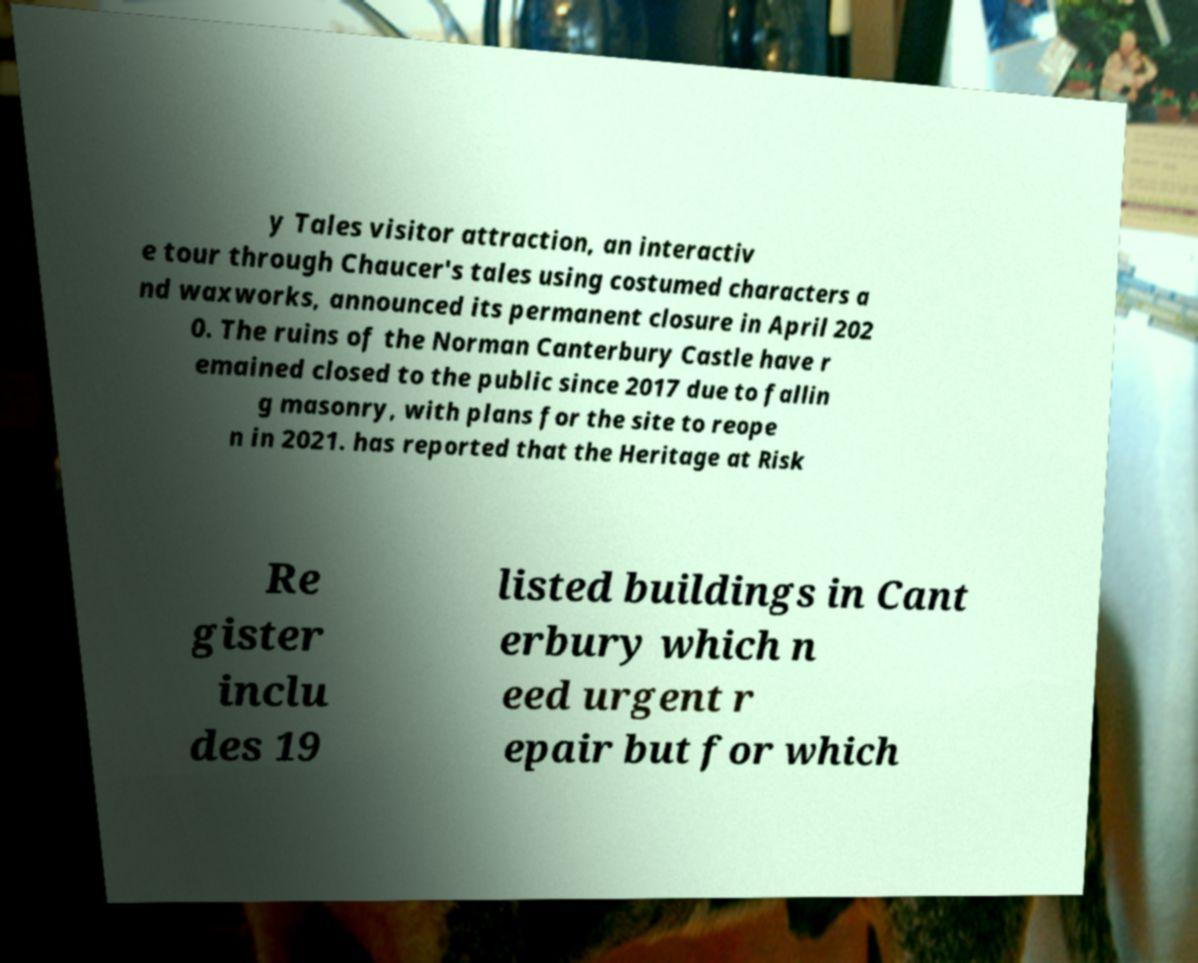Could you assist in decoding the text presented in this image and type it out clearly? y Tales visitor attraction, an interactiv e tour through Chaucer's tales using costumed characters a nd waxworks, announced its permanent closure in April 202 0. The ruins of the Norman Canterbury Castle have r emained closed to the public since 2017 due to fallin g masonry, with plans for the site to reope n in 2021. has reported that the Heritage at Risk Re gister inclu des 19 listed buildings in Cant erbury which n eed urgent r epair but for which 